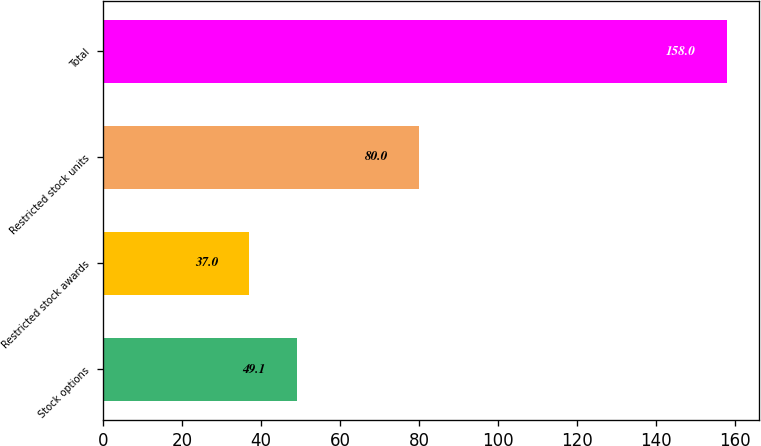Convert chart. <chart><loc_0><loc_0><loc_500><loc_500><bar_chart><fcel>Stock options<fcel>Restricted stock awards<fcel>Restricted stock units<fcel>Total<nl><fcel>49.1<fcel>37<fcel>80<fcel>158<nl></chart> 